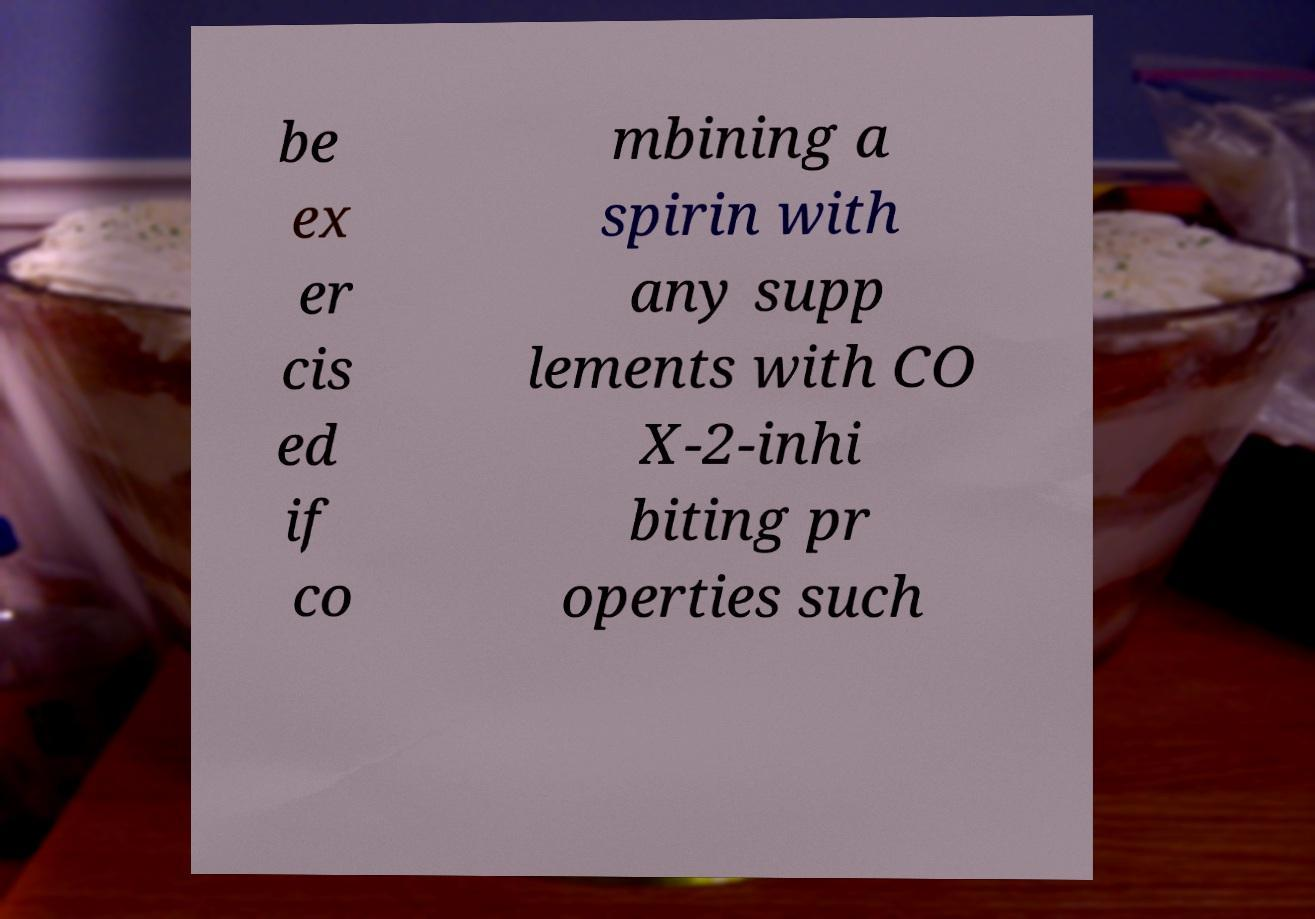What messages or text are displayed in this image? I need them in a readable, typed format. be ex er cis ed if co mbining a spirin with any supp lements with CO X-2-inhi biting pr operties such 